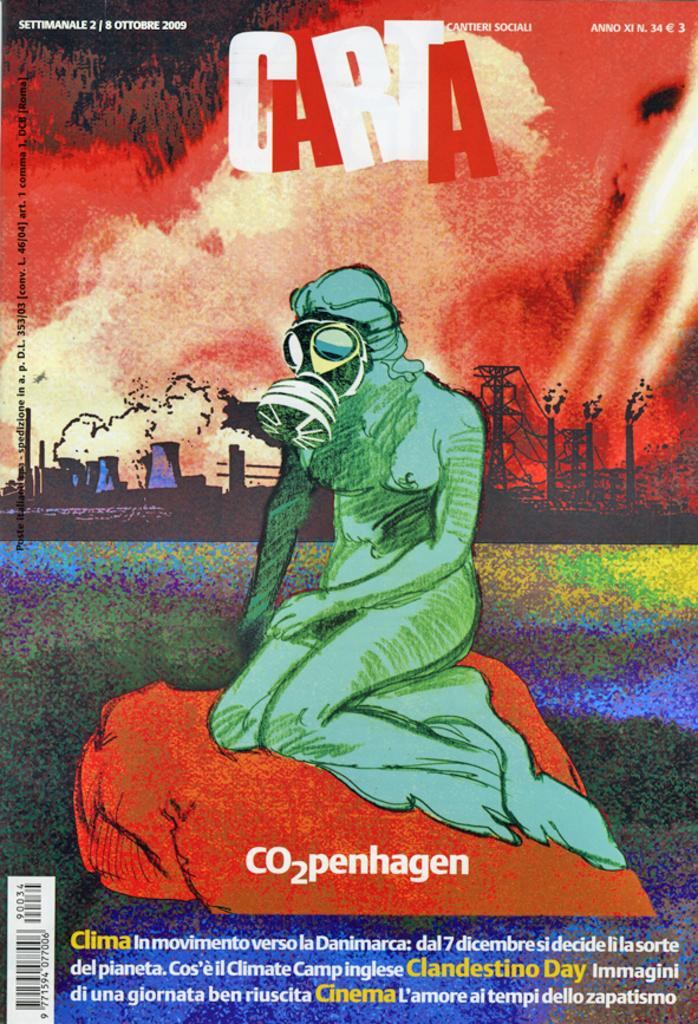Provide a one-sentence caption for the provided image. A promotional poster with a person wearing a gas mask for C02penhagen. 